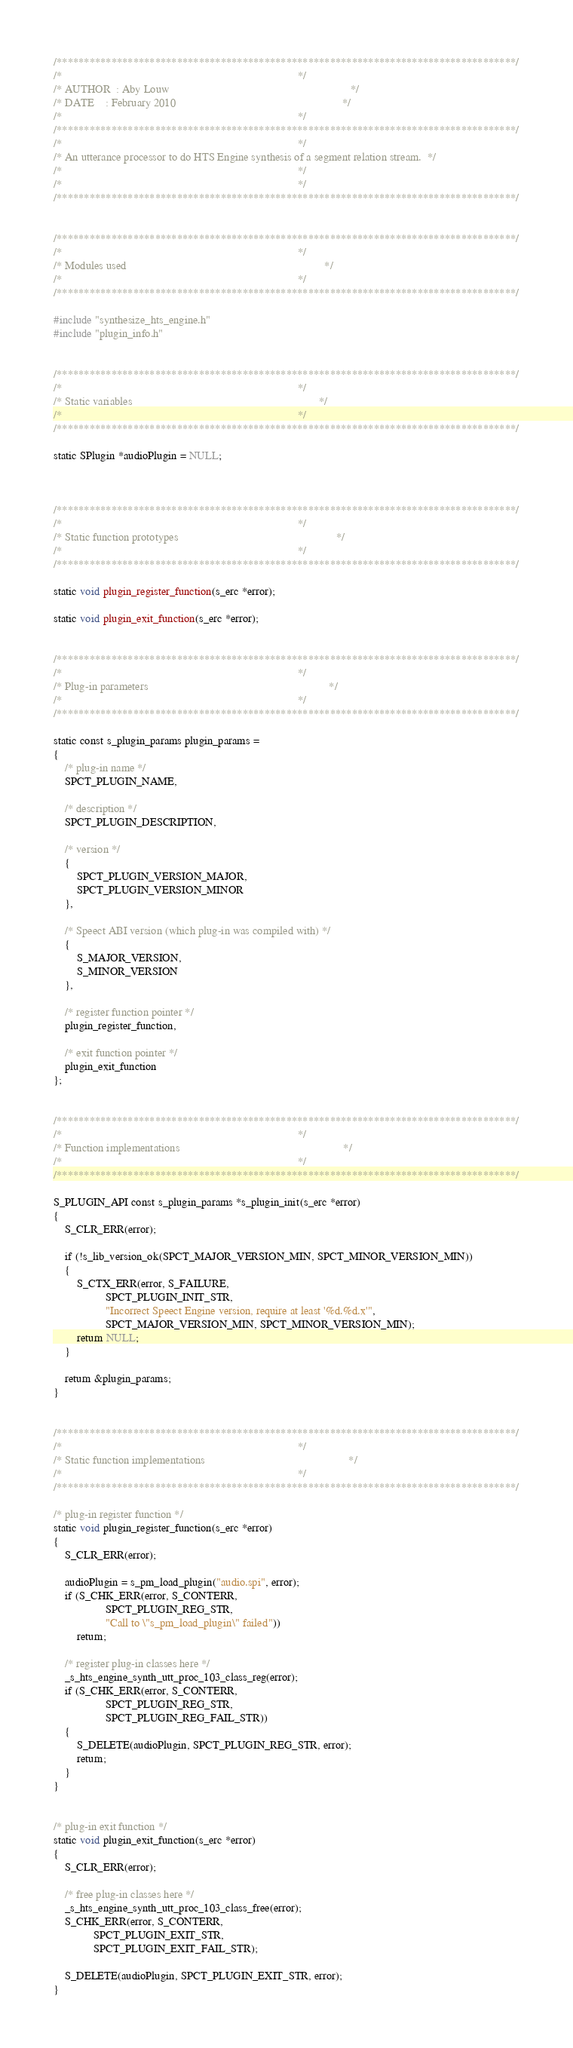<code> <loc_0><loc_0><loc_500><loc_500><_C_>/************************************************************************************/
/*                                                                                  */
/* AUTHOR  : Aby Louw                                                               */
/* DATE    : February 2010                                                          */
/*                                                                                  */
/************************************************************************************/
/*                                                                                  */
/* An utterance processor to do HTS Engine synthesis of a segment relation stream.  */
/*                                                                                  */
/*                                                                                  */
/************************************************************************************/


/************************************************************************************/
/*                                                                                  */
/* Modules used                                                                     */
/*                                                                                  */
/************************************************************************************/

#include "synthesize_hts_engine.h"
#include "plugin_info.h"


/************************************************************************************/
/*                                                                                  */
/* Static variables                                                                 */
/*                                                                                  */
/************************************************************************************/

static SPlugin *audioPlugin = NULL;



/************************************************************************************/
/*                                                                                  */
/* Static function prototypes                                                       */
/*                                                                                  */
/************************************************************************************/

static void plugin_register_function(s_erc *error);

static void plugin_exit_function(s_erc *error);


/************************************************************************************/
/*                                                                                  */
/* Plug-in parameters                                                               */
/*                                                                                  */
/************************************************************************************/

static const s_plugin_params plugin_params =
{
	/* plug-in name */
	SPCT_PLUGIN_NAME,

	/* description */
	SPCT_PLUGIN_DESCRIPTION,

	/* version */
	{
		SPCT_PLUGIN_VERSION_MAJOR,
		SPCT_PLUGIN_VERSION_MINOR
	},

	/* Speect ABI version (which plug-in was compiled with) */
	{
		S_MAJOR_VERSION,
		S_MINOR_VERSION
	},

	/* register function pointer */
	plugin_register_function,

	/* exit function pointer */
	plugin_exit_function
};


/************************************************************************************/
/*                                                                                  */
/* Function implementations                                                         */
/*                                                                                  */
/************************************************************************************/

S_PLUGIN_API const s_plugin_params *s_plugin_init(s_erc *error)
{
	S_CLR_ERR(error);

	if (!s_lib_version_ok(SPCT_MAJOR_VERSION_MIN, SPCT_MINOR_VERSION_MIN))
	{
		S_CTX_ERR(error, S_FAILURE,
				  SPCT_PLUGIN_INIT_STR,
				  "Incorrect Speect Engine version, require at least '%d.%d.x'",
				  SPCT_MAJOR_VERSION_MIN, SPCT_MINOR_VERSION_MIN);
		return NULL;
	}

	return &plugin_params;
}


/************************************************************************************/
/*                                                                                  */
/* Static function implementations                                                  */
/*                                                                                  */
/************************************************************************************/

/* plug-in register function */
static void plugin_register_function(s_erc *error)
{
	S_CLR_ERR(error);

	audioPlugin = s_pm_load_plugin("audio.spi", error);
	if (S_CHK_ERR(error, S_CONTERR,
				  SPCT_PLUGIN_REG_STR,
				  "Call to \"s_pm_load_plugin\" failed"))
		return;

	/* register plug-in classes here */
	_s_hts_engine_synth_utt_proc_103_class_reg(error);
	if (S_CHK_ERR(error, S_CONTERR,
				  SPCT_PLUGIN_REG_STR,
				  SPCT_PLUGIN_REG_FAIL_STR))
	{
		S_DELETE(audioPlugin, SPCT_PLUGIN_REG_STR, error);
		return;
	}
}


/* plug-in exit function */
static void plugin_exit_function(s_erc *error)
{
	S_CLR_ERR(error);

	/* free plug-in classes here */
	_s_hts_engine_synth_utt_proc_103_class_free(error);
	S_CHK_ERR(error, S_CONTERR,
			  SPCT_PLUGIN_EXIT_STR,
			  SPCT_PLUGIN_EXIT_FAIL_STR);

	S_DELETE(audioPlugin, SPCT_PLUGIN_EXIT_STR, error);
}
</code> 